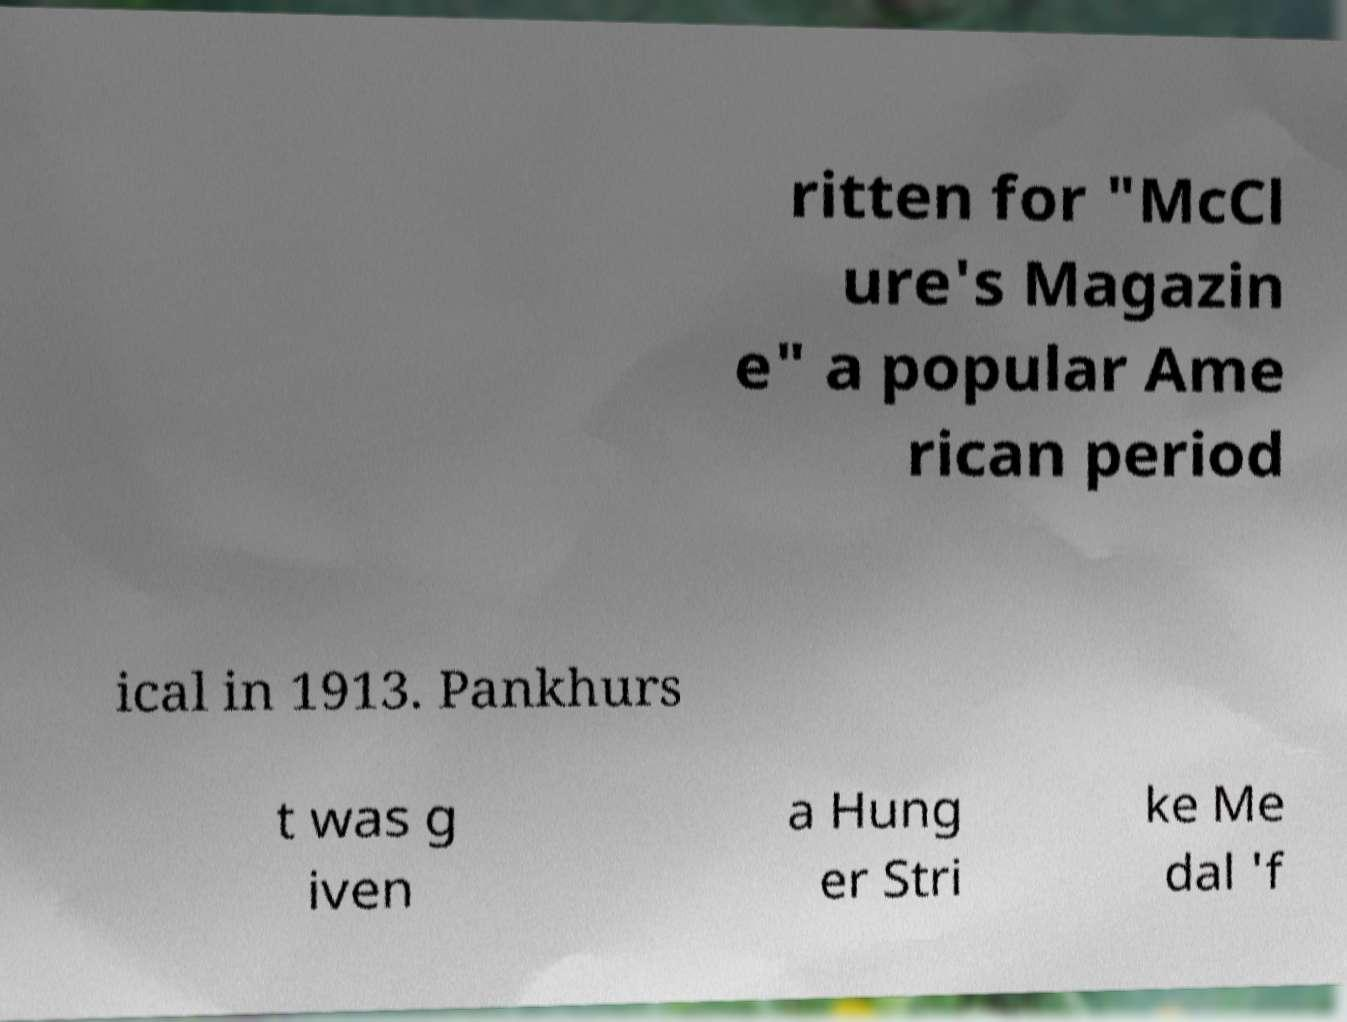What messages or text are displayed in this image? I need them in a readable, typed format. ritten for "McCl ure's Magazin e" a popular Ame rican period ical in 1913. Pankhurs t was g iven a Hung er Stri ke Me dal 'f 